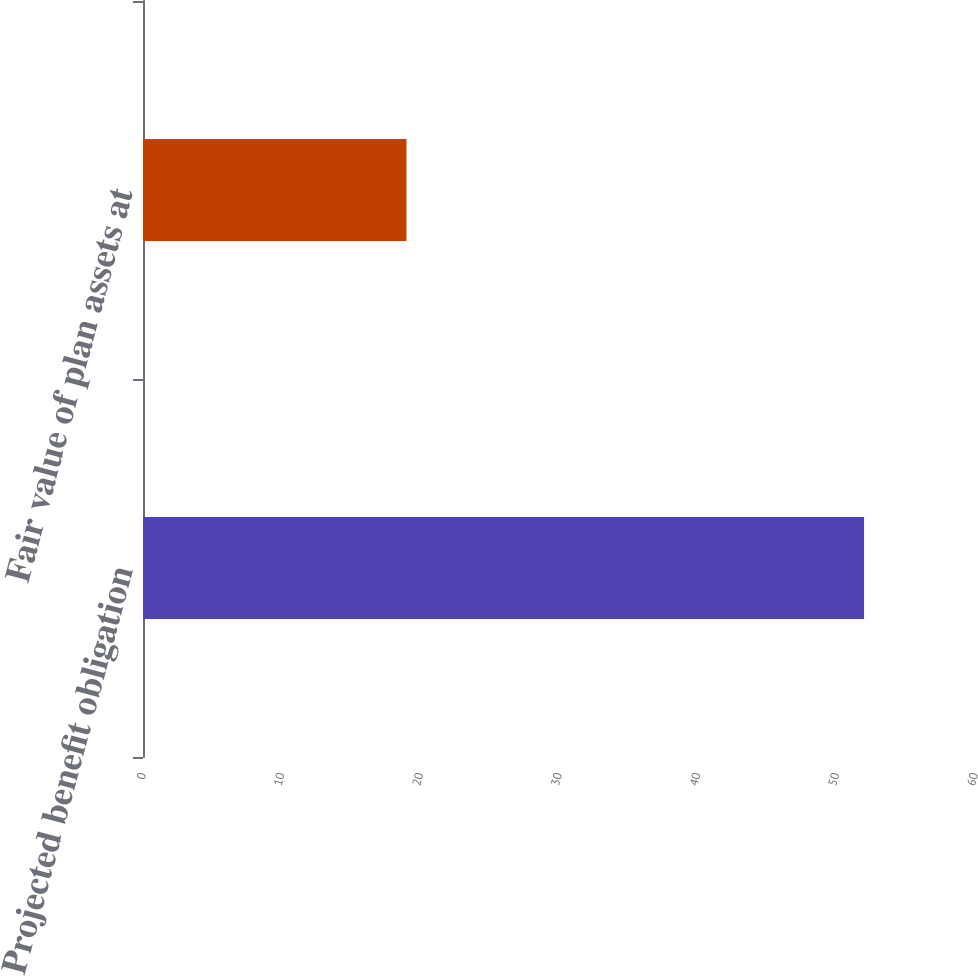Convert chart to OTSL. <chart><loc_0><loc_0><loc_500><loc_500><bar_chart><fcel>Projected benefit obligation<fcel>Fair value of plan assets at<nl><fcel>52<fcel>19<nl></chart> 